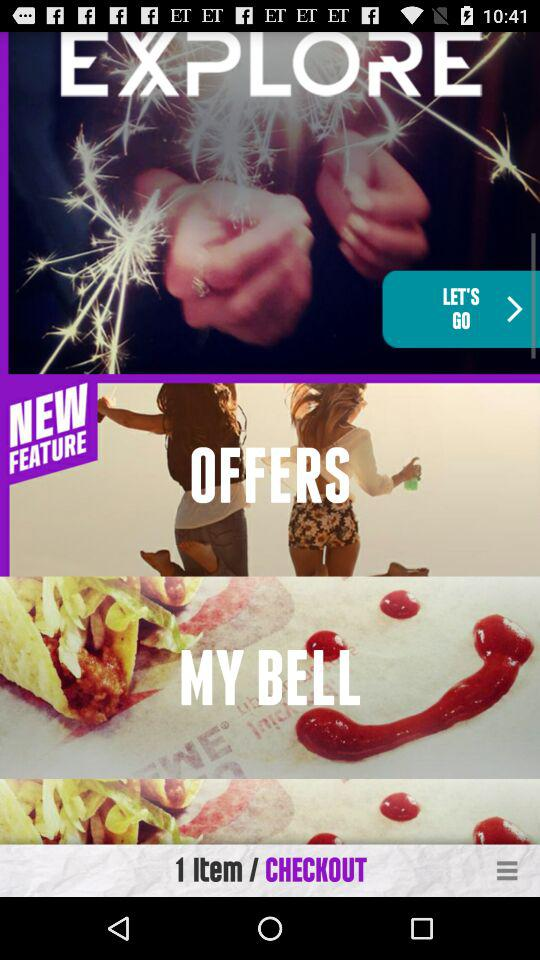How many items are in the shopping cart?
Answer the question using a single word or phrase. 1 